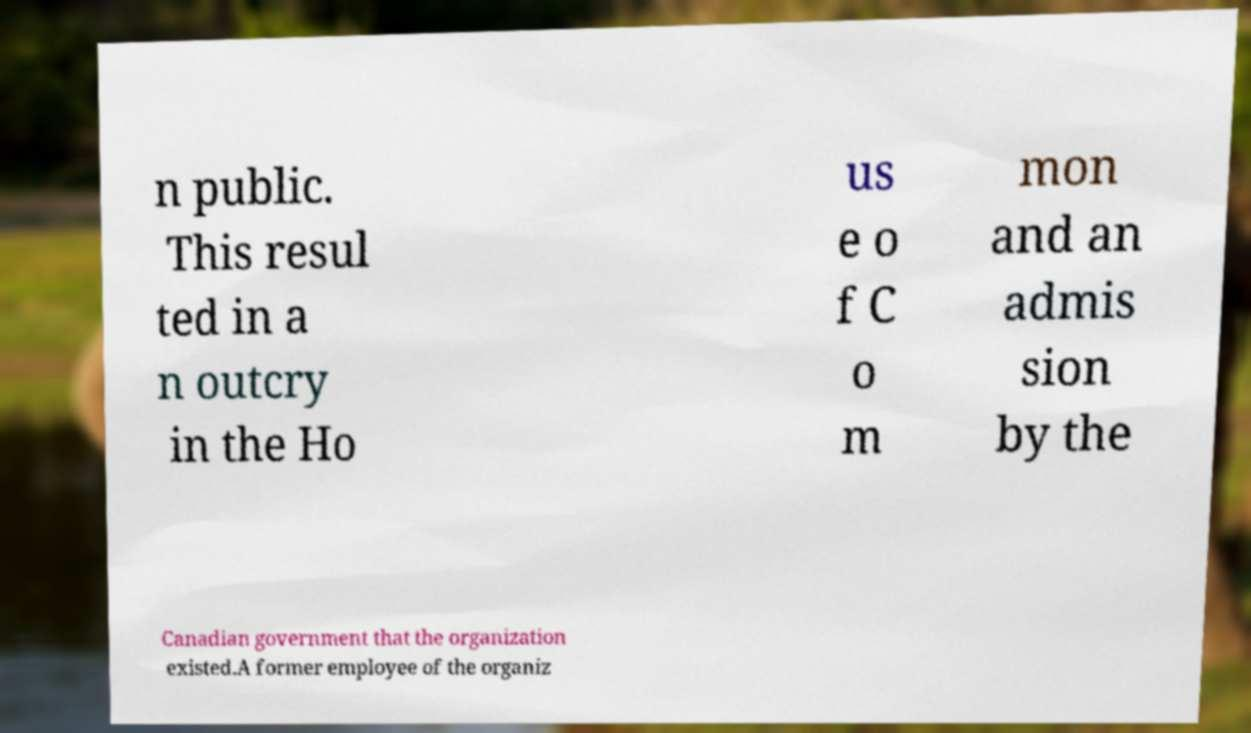For documentation purposes, I need the text within this image transcribed. Could you provide that? n public. This resul ted in a n outcry in the Ho us e o f C o m mon and an admis sion by the Canadian government that the organization existed.A former employee of the organiz 